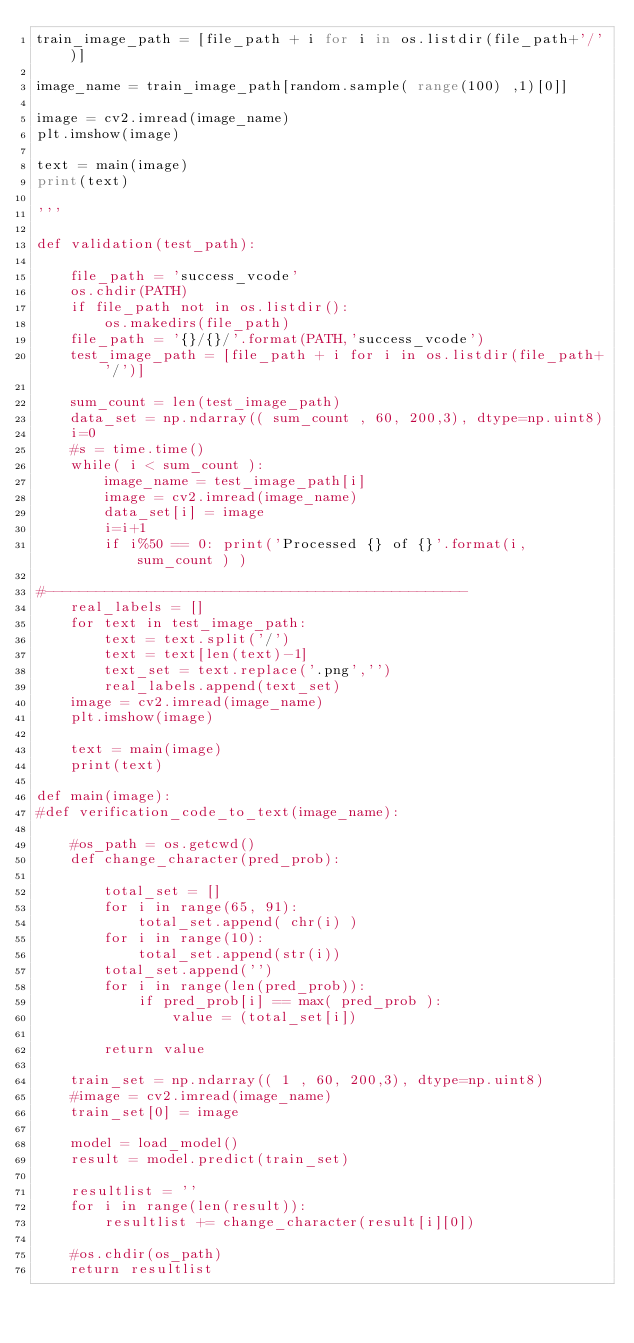<code> <loc_0><loc_0><loc_500><loc_500><_Python_>train_image_path = [file_path + i for i in os.listdir(file_path+'/')]

image_name = train_image_path[random.sample( range(100) ,1)[0]]

image = cv2.imread(image_name)
plt.imshow(image)

text = main(image)
print(text)

'''

def validation(test_path):
    
    file_path = 'success_vcode'
    os.chdir(PATH)
    if file_path not in os.listdir():
        os.makedirs(file_path)
    file_path = '{}/{}/'.format(PATH,'success_vcode')
    test_image_path = [file_path + i for i in os.listdir(file_path+'/')]
    
    sum_count = len(test_image_path)
    data_set = np.ndarray(( sum_count , 60, 200,3), dtype=np.uint8)
    i=0
    #s = time.time()
    while( i < sum_count ):
        image_name = test_image_path[i]
        image = cv2.imread(image_name)
        data_set[i] = image
        i=i+1
        if i%50 == 0: print('Processed {} of {}'.format(i, sum_count ) )
            
#--------------------------------------------------
    real_labels = []
    for text in test_image_path:
        text = text.split('/')
        text = text[len(text)-1]
        text_set = text.replace('.png','')
        real_labels.append(text_set)
    image = cv2.imread(image_name)
    plt.imshow(image)
    
    text = main(image)
    print(text)

def main(image):
#def verification_code_to_text(image_name):
    
    #os_path = os.getcwd()
    def change_character(pred_prob):
        
        total_set = []
        for i in range(65, 91):
            total_set.append( chr(i) )
        for i in range(10):
            total_set.append(str(i))
        total_set.append('')
        for i in range(len(pred_prob)):
            if pred_prob[i] == max( pred_prob ):
                value = (total_set[i])

        return value
    
    train_set = np.ndarray(( 1 , 60, 200,3), dtype=np.uint8)
    #image = cv2.imread(image_name)
    train_set[0] = image

    model = load_model()
    result = model.predict(train_set)

    resultlist = ''
    for i in range(len(result)):
        resultlist += change_character(result[i][0])

    #os.chdir(os_path)
    return resultlist



</code> 